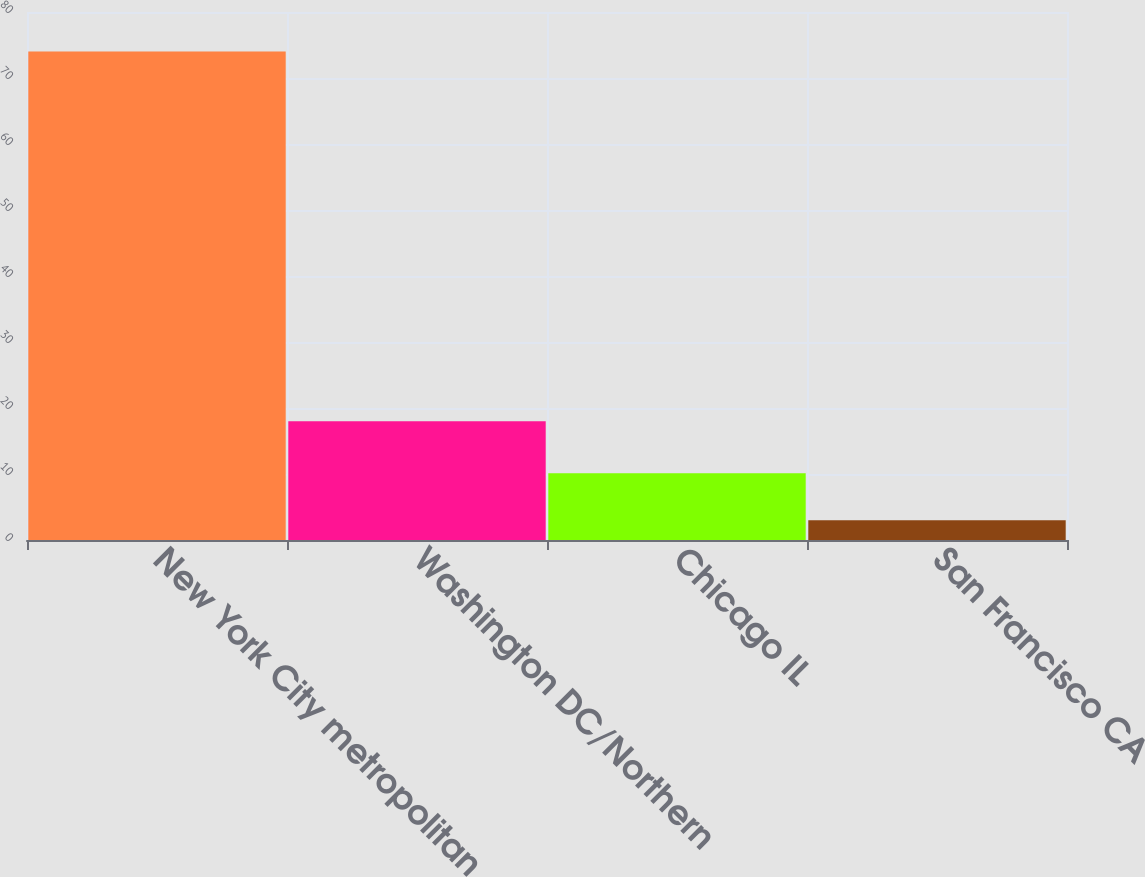<chart> <loc_0><loc_0><loc_500><loc_500><bar_chart><fcel>New York City metropolitan<fcel>Washington DC/Northern<fcel>Chicago IL<fcel>San Francisco CA<nl><fcel>74<fcel>18<fcel>10.1<fcel>3<nl></chart> 